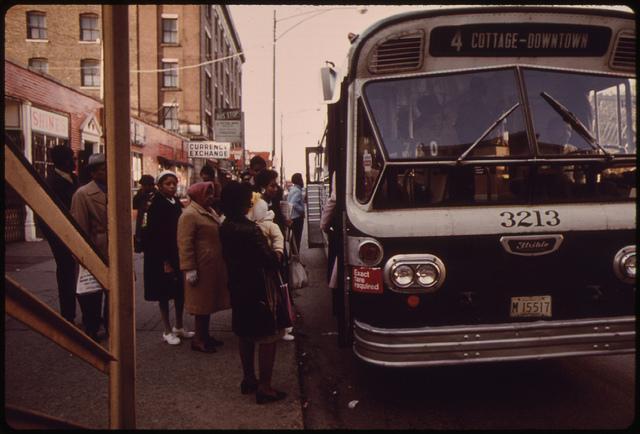How many people can you see?
Give a very brief answer. 6. 